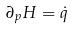Convert formula to latex. <formula><loc_0><loc_0><loc_500><loc_500>\partial _ { p } H = \dot { q }</formula> 